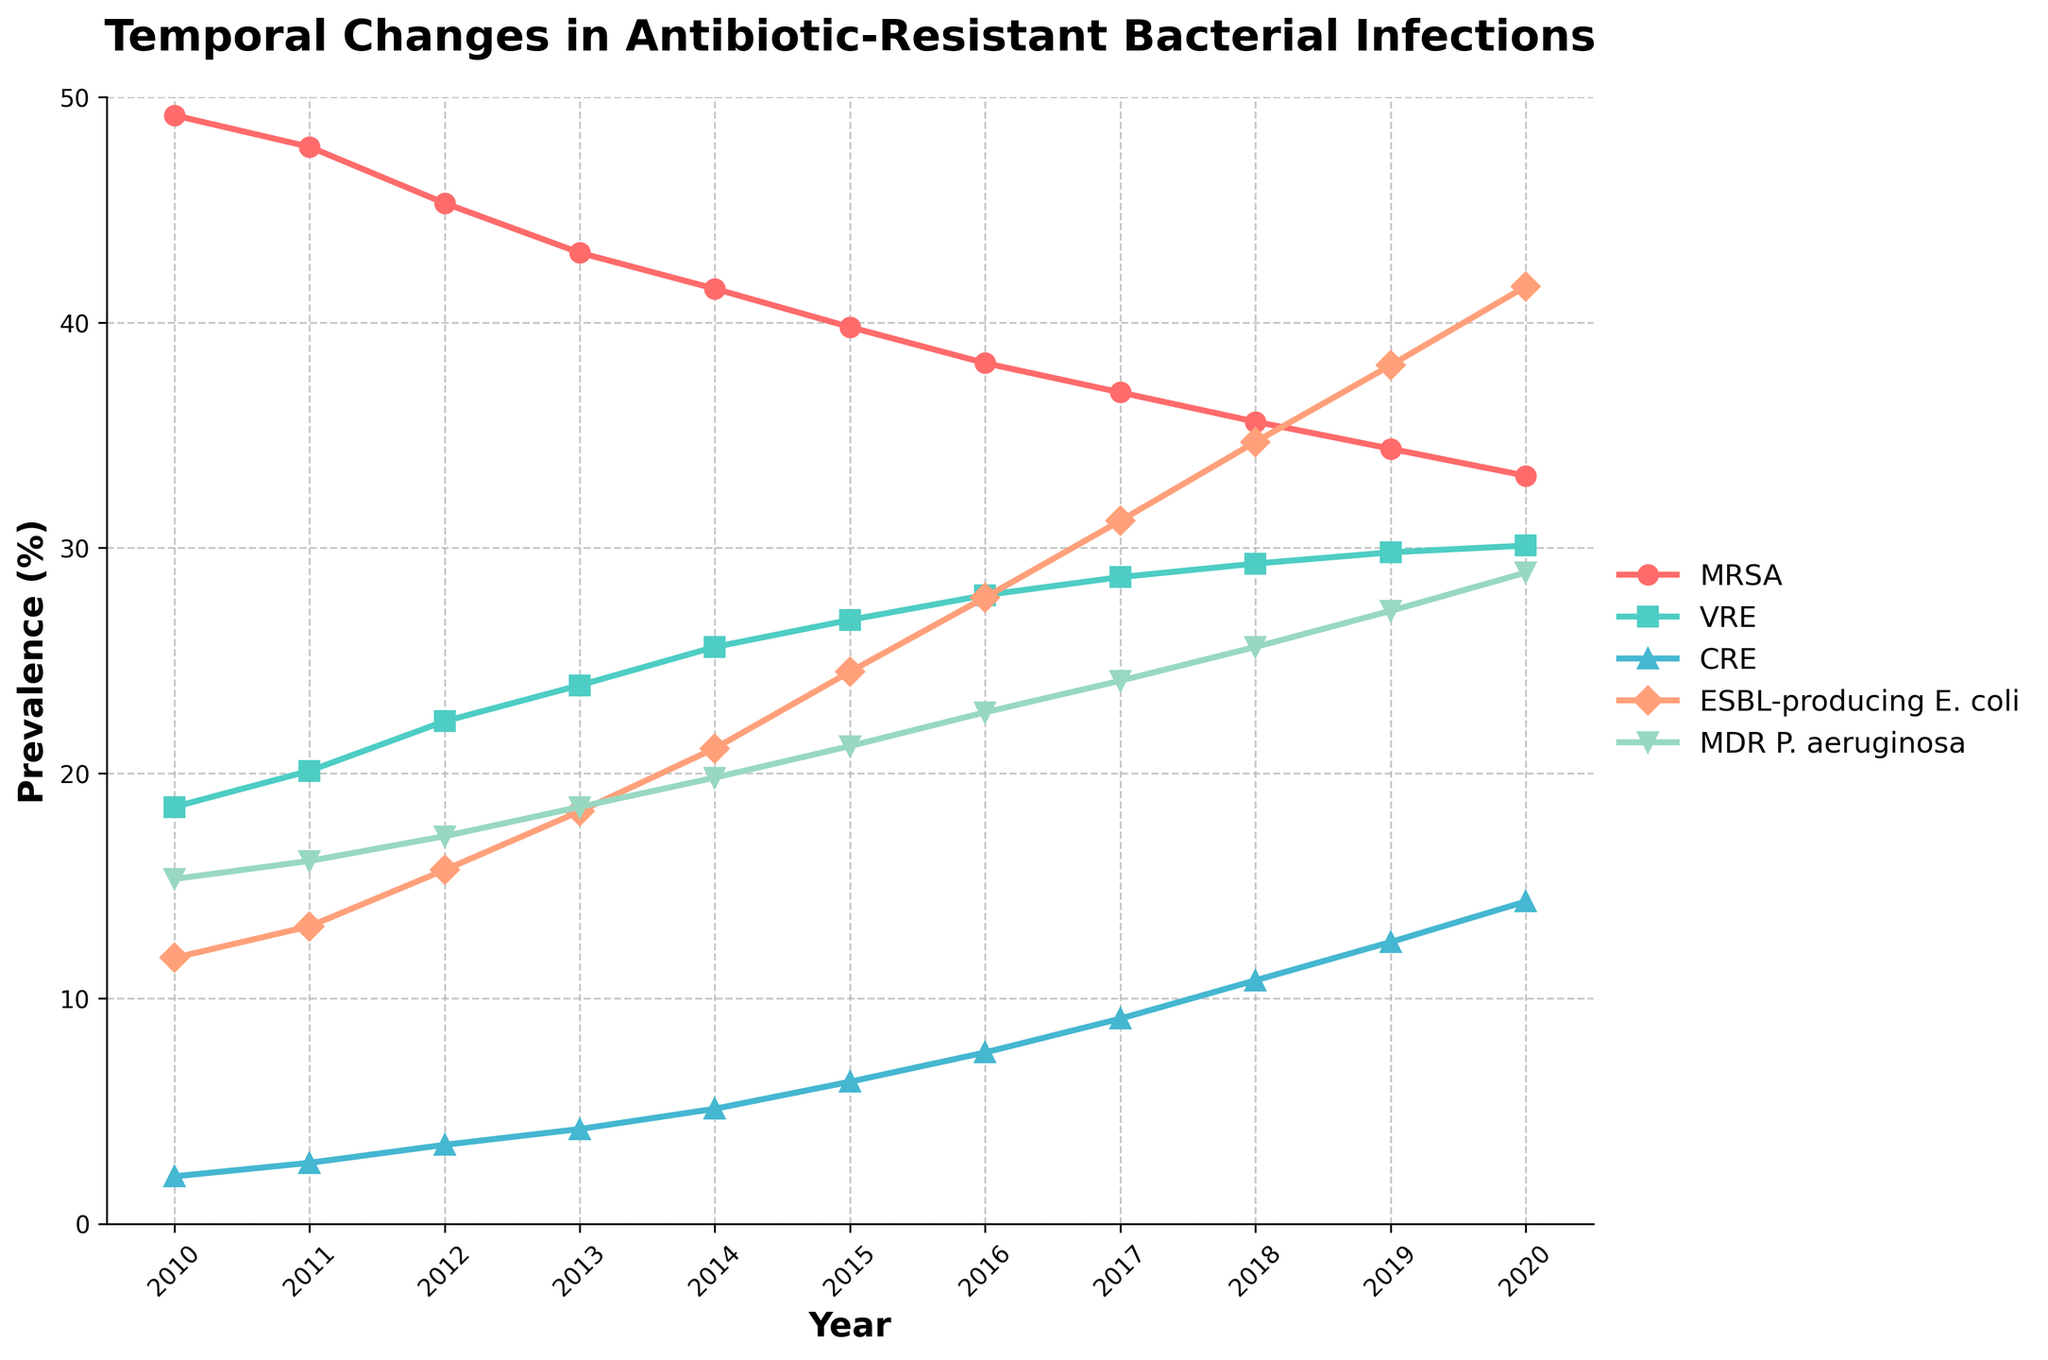Which antibiotic-resistant bacteria showed the highest prevalence in 2010? To find the bacteria with the highest prevalence in 2010, look at the starting point (leftmost side) of the lines on the chart. The bacteria with the highest starting point on the vertical axis is the one with the highest prevalence. MRSA shows the highest prevalence.
Answer: MRSA What is the average prevalence of CRE from 2010 to 2020? First, sum the prevalence values of CRE from 2010 to 2020: 2.1 + 2.7 + 3.5 + 4.2 + 5.1 + 6.3 + 7.6 + 9.1 + 10.8 + 12.5 + 14.3 = 78.2. Divide this sum by the number of years (11) to get the average: 78.2 / 11 = 7.11.
Answer: 7.11 How did the prevalence of ESBL-producing E. coli change from 2010 to 2020? Look at the starting and ending points of the ESBL-producing E. coli line on the vertical axis. The prevalence starts at 11.8% in 2010 and ends at 41.6% in 2020. Subtract the initial value from the final value: 41.6 - 11.8 = 29.8.
Answer: Increased by 29.8% Which bacterial infection had the smallest increase in prevalence over the period from 2010 to 2020? To find this, subtract the 2010 value from the 2020 value for each bacterial infection and compare these differences. The differences are: MRSA: 49.2 - 33.2 = 16, VRE: 30.1 - 18.5 = 11.6, CRE: 14.3 - 2.1 = 12.2, ESBL-producing E. coli: 41.6 - 11.8 = 29.8, MDR P. aeruginosa: 28.9 - 15.3 = 13.6. VRE shows the smallest increase.
Answer: VRE What is the difference in prevalence between MRSA and MDR P. aeruginosa in 2020? Look at the prevalence values of MRSA and MDR P. aeruginosa in 2020: MRSA: 33.2, MDR P. aeruginosa: 28.9. Subtract the latter from the former: 33.2 - 28.9 = 4.3.
Answer: 4.3 Which antibiotic-resistant bacteria had a continuous increase in prevalence from 2010 to 2020? Identify the lines on the chart that continuously go up from left to right without any decrease. These are CRE, ESBL-producing E. coli, MDR P. aeruginosa, and VRE.
Answer: CRE, ESBL-producing E. coli, MDR P. aeruginosa, VRE In which year did the prevalence of VRE overtake the prevalence of MRSA? Look for the year in the chart when the line representing VRE crosses above the line representing MRSA. This occurs between 2018 and 2019.
Answer: Between 2018 and 2019 Which year saw the sharpest increase in the prevalence of ESBL-producing E. coli? Find the segment of the ESBL-producing E. coli line with the steepest upward slope. The largest increase is observed between 2011 (13.2%) and 2012 (15.7%) with an increase of 2.5.
Answer: 2012 What is the total combined prevalence of all antibiotic-resistant bacteria in 2019? Sum the prevalence values for all antibiotic-resistant bacteria in 2019: MRSA: 34.4, VRE: 29.8, CRE: 12.5, ESBL-producing E. coli: 38.1, MDR P. aeruginosa: 27.2. Summing these values: 34.4 + 29.8 + 12.5 + 38.1 + 27.2 = 142.
Answer: 142 